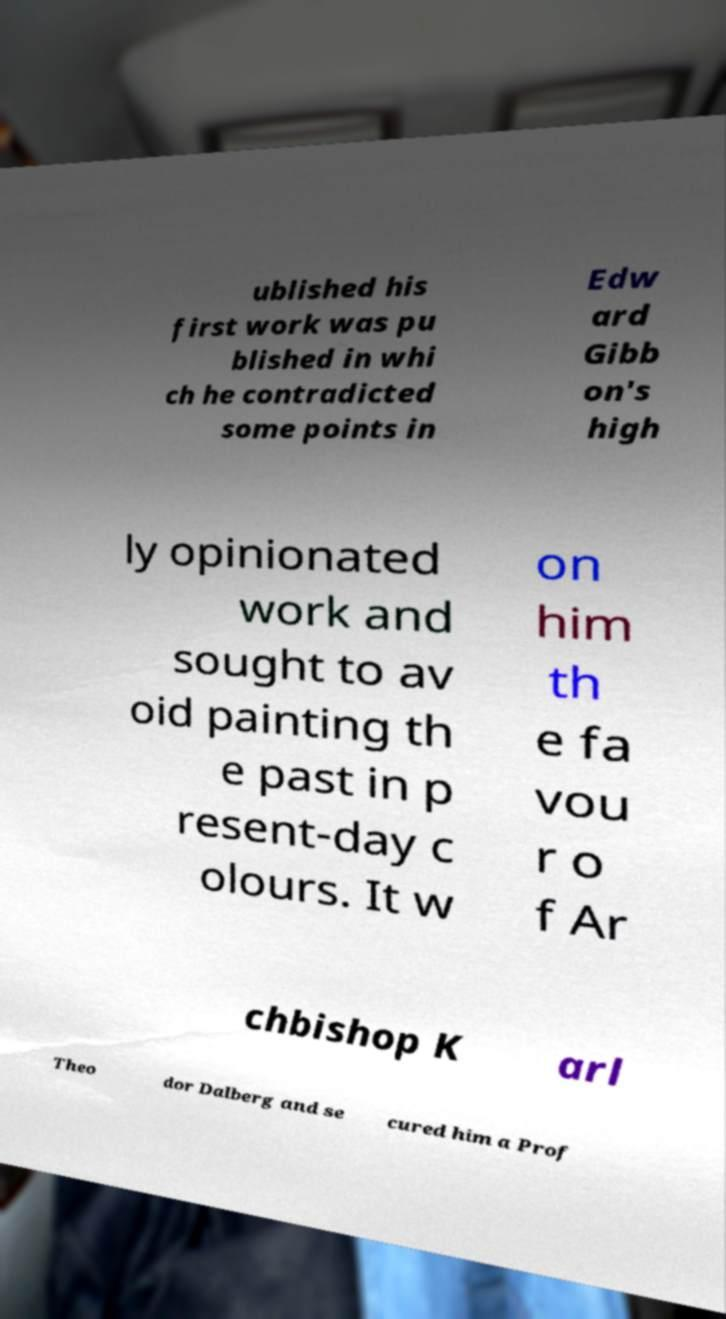I need the written content from this picture converted into text. Can you do that? ublished his first work was pu blished in whi ch he contradicted some points in Edw ard Gibb on's high ly opinionated work and sought to av oid painting th e past in p resent-day c olours. It w on him th e fa vou r o f Ar chbishop K arl Theo dor Dalberg and se cured him a Prof 